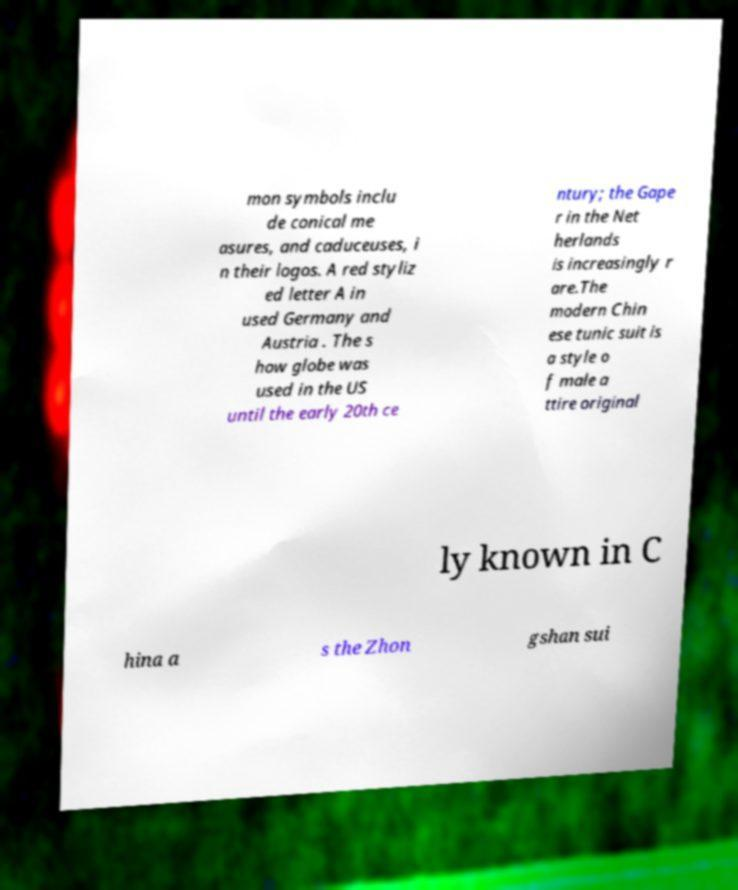Could you extract and type out the text from this image? mon symbols inclu de conical me asures, and caduceuses, i n their logos. A red styliz ed letter A in used Germany and Austria . The s how globe was used in the US until the early 20th ce ntury; the Gape r in the Net herlands is increasingly r are.The modern Chin ese tunic suit is a style o f male a ttire original ly known in C hina a s the Zhon gshan sui 